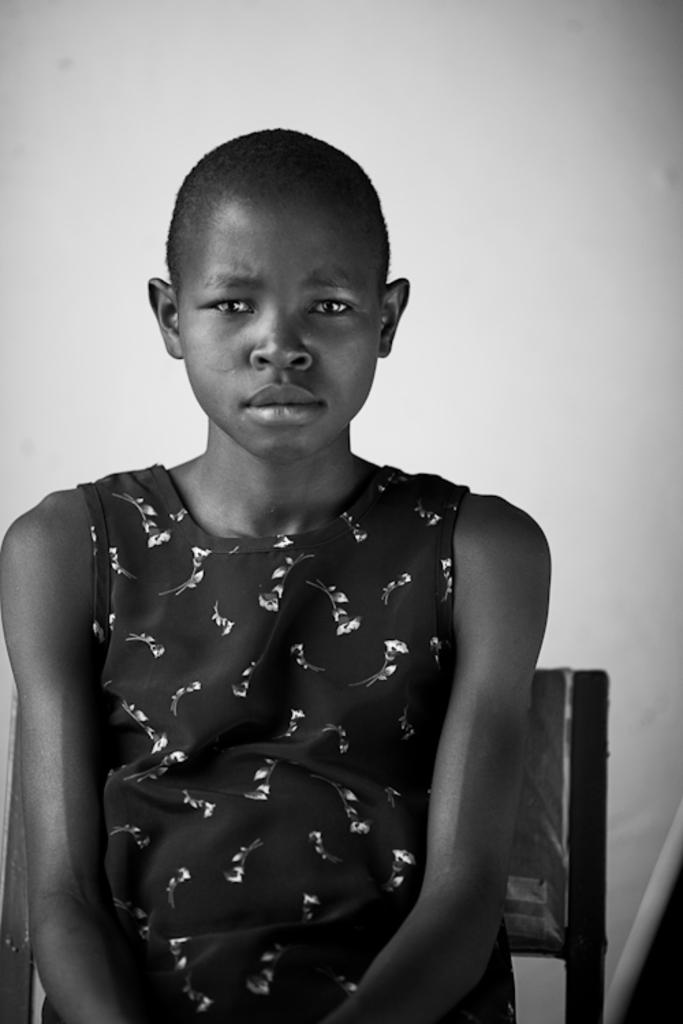What is the color scheme of the image? The image is black and white. Who or what is the main subject in the image? There is a girl in the image. What is the girl doing in the image? The girl is sitting on a chair. Where is the grandmother in the image? There is no grandmother present in the image. What type of key is the girl holding in the image? There is no key visible in the image. 